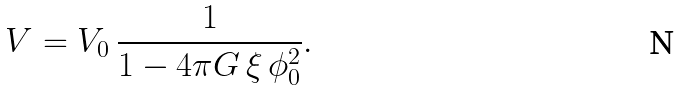<formula> <loc_0><loc_0><loc_500><loc_500>V = V _ { 0 } \, \frac { 1 } { 1 - 4 \pi G \, \xi \, \phi _ { 0 } ^ { 2 } } .</formula> 